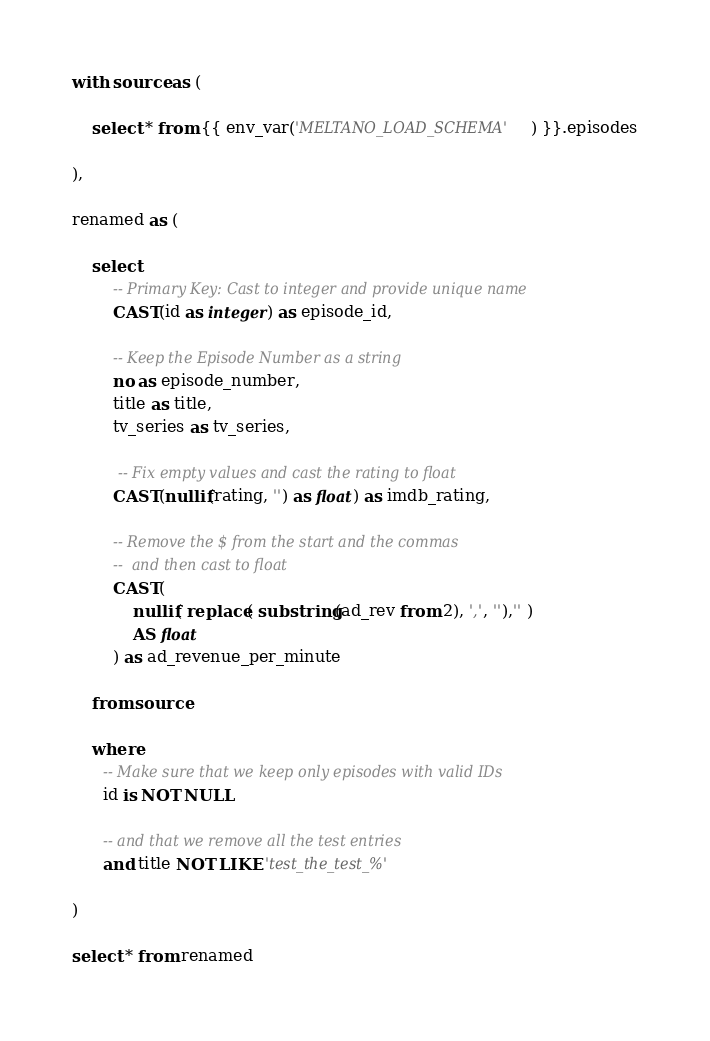<code> <loc_0><loc_0><loc_500><loc_500><_SQL_>with source as (

    select * from {{ env_var('MELTANO_LOAD_SCHEMA') }}.episodes

),

renamed as (

    select
        -- Primary Key: Cast to integer and provide unique name
        CAST(id as integer) as episode_id,

        -- Keep the Episode Number as a string
        no as episode_number,
        title as title,
        tv_series as tv_series,

         -- Fix empty values and cast the rating to float
        CAST(nullif(rating, '') as float) as imdb_rating,

        -- Remove the $ from the start and the commas
        --  and then cast to float
        CAST(
            nullif( replace( substring(ad_rev from 2), ',', ''),'' )
            AS float
        ) as ad_revenue_per_minute

    from source

    where
      -- Make sure that we keep only episodes with valid IDs
      id is NOT NULL

      -- and that we remove all the test entries
      and title NOT LIKE 'test_the_test_%'

)

select * from renamed</code> 